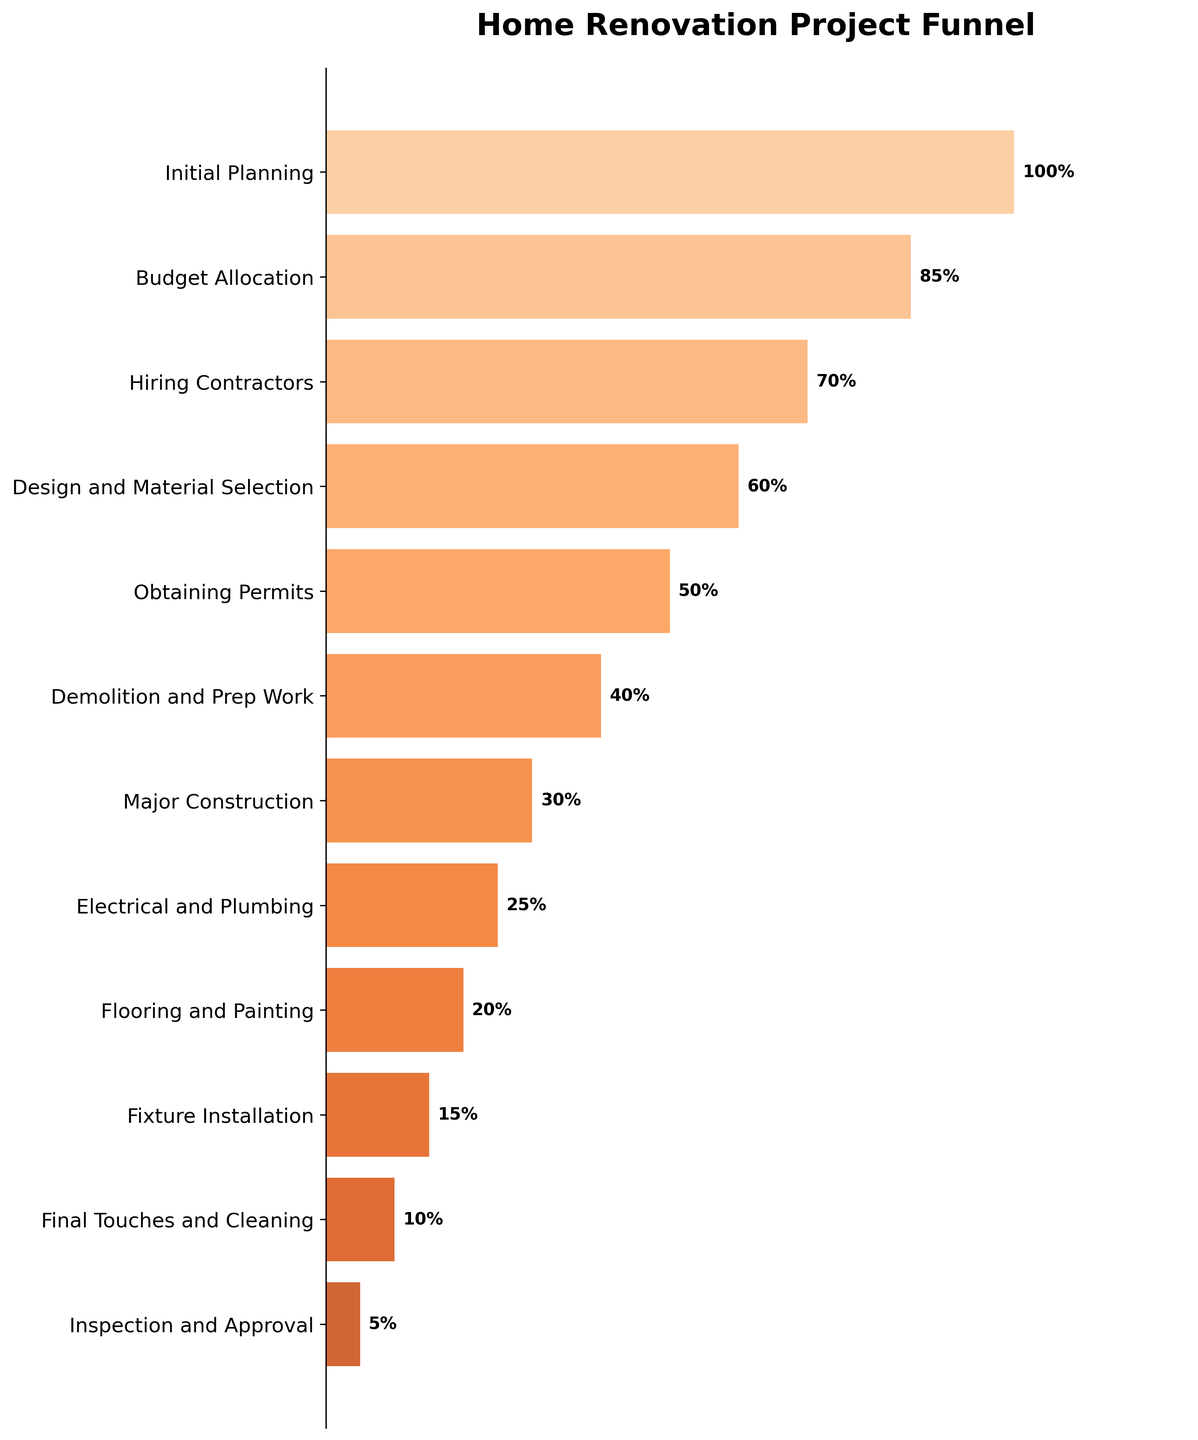How many phases are there in the home renovation project? Count the number of items listed on the y-axis in the funnel chart. There are 12 phases.
Answer: 12 Which phase has the lowest percentage completion? Observe the last bar at the bottom of the funnel, which is labeled with the lowest percentage value. The "Inspection and Approval" phase has the lowest completion at 5%.
Answer: Inspection and Approval What is the percentage completion for the "Major Construction" phase? Look for the "Major Construction" phase on the y-axis and read its corresponding percentage completion. The percentage is 30%.
Answer: 30% Calculate the difference in percentage completion between "Initial Planning" and "Hiring Contractors". Subtract the percentage of "Hiring Contractors" from "Initial Planning": 100% - 70% = 30%.
Answer: 30% Which phase has a higher percentage completion: "Obtaining Permits" or "Fixture Installation"? Compare the percentages of "Obtaining Permits" (50%) and "Fixture Installation" (15%). "Obtaining Permits" has a higher percentage completion.
Answer: Obtaining Permits What percentage of the project is completed by the "Design and Material Selection" phase? Read the percentage for the "Design and Material Selection" phase from the chart. The percentage is 60%.
Answer: 60% Compare the completion percentages of "Electrical and Plumbing" and "Flooring and Painting". Which is higher and by how much? "Electrical and Plumbing" is at 25% and "Flooring and Painting" is at 20%. The difference is 5% (25% - 20%).
Answer: Electrical and Plumbing by 5% What is the average percentage completion across the "Obtaining Permits", "Demolition and Prep Work", and "Electrical and Plumbing" phases? Add the percentages (50% + 40% + 25%) and divide by the number of phases (3): (50 + 40 + 25) / 3 = 38.33%.
Answer: 38.33% At which phase does the project reach below 50% completion? Identify the phase where the percentage drops below 50% for the first time: The "Obtaining Permits" phase is the last one above 50%, so the phase following it ("Demolition and Prep Work") is below 50%.
Answer: Demolition and Prep Work How does the width of the bars change as you move down the funnel? Observe the bars' widths from top to bottom; the widths gradually decrease as the percentage completion reduces.
Answer: Decreases 